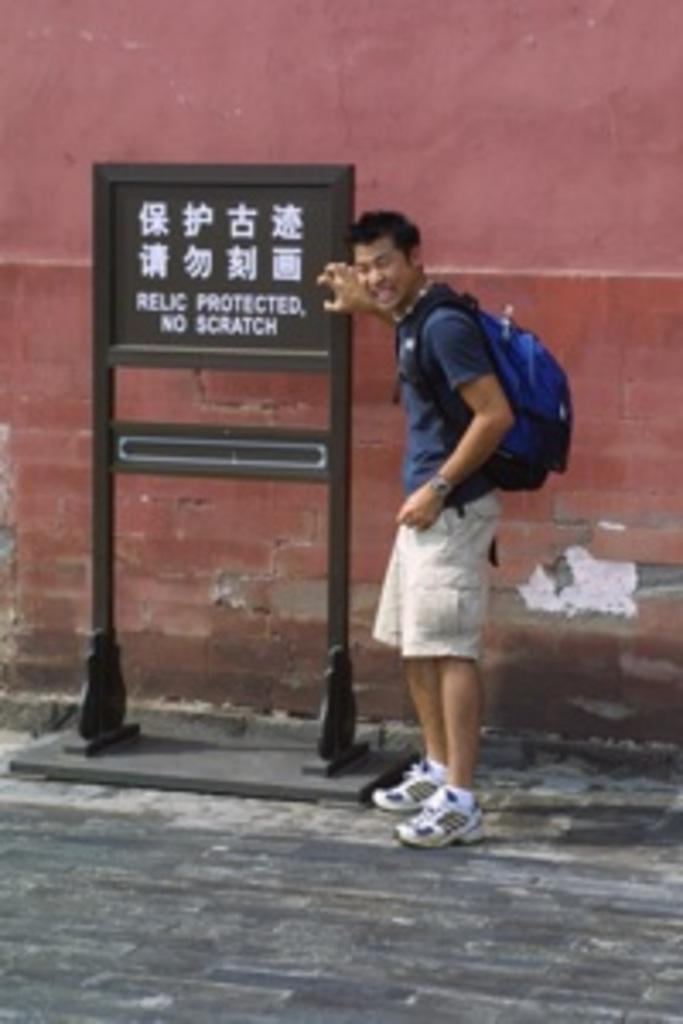What is the main subject in the image? There is a man standing in the image. What object is present in the image along with the man? There is a board in the image. What can be seen on the board? There is text on the board. What can be seen in the background of the image? There is a wall in the background of the image. What is visible at the bottom of the image? There is a road at the bottom of the image. How many snakes are crawling on the man in the image? There are no snakes present in the image; the man is standing alone. What is the girl doing in the image? There is no girl present in the image. 